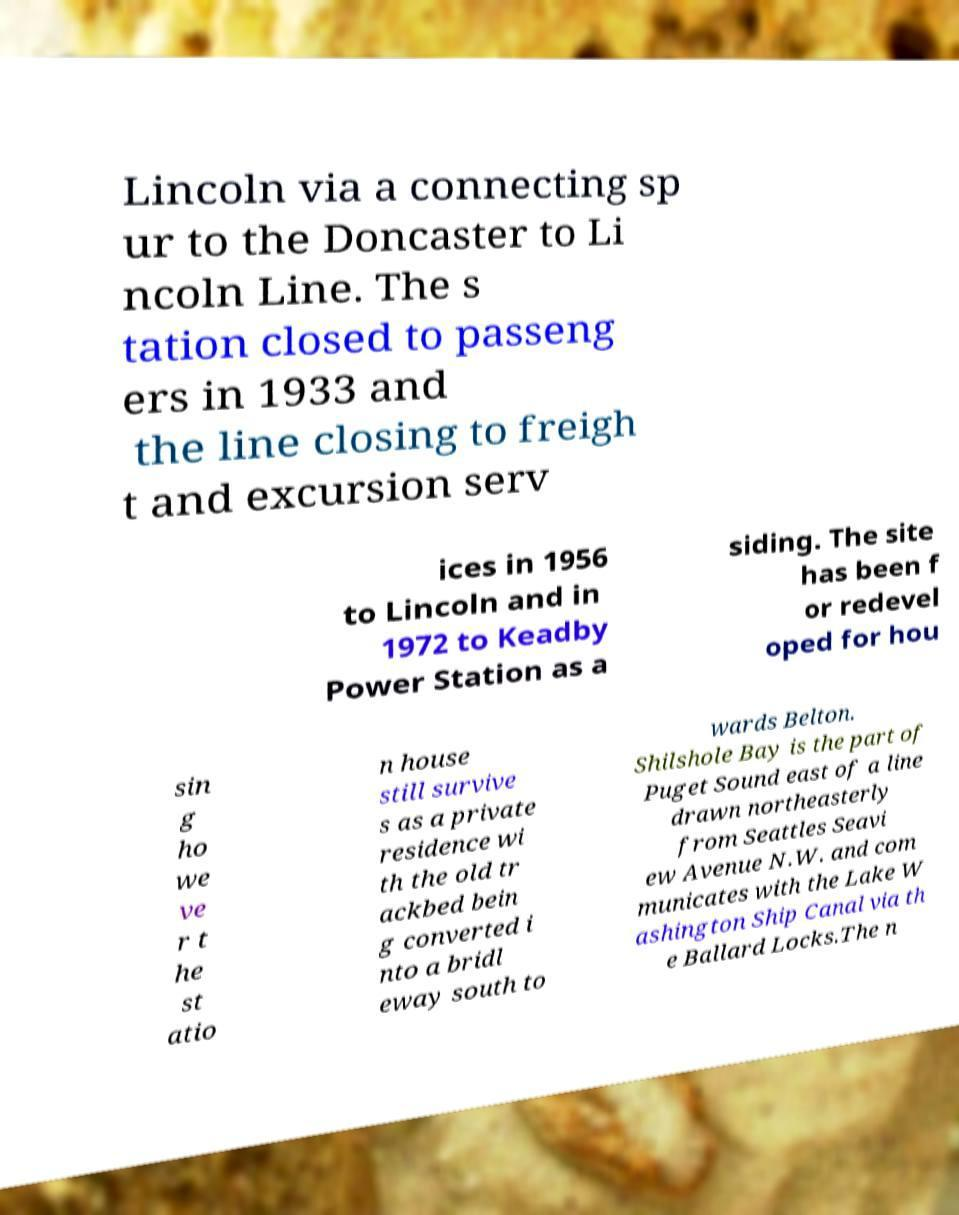Could you assist in decoding the text presented in this image and type it out clearly? Lincoln via a connecting sp ur to the Doncaster to Li ncoln Line. The s tation closed to passeng ers in 1933 and the line closing to freigh t and excursion serv ices in 1956 to Lincoln and in 1972 to Keadby Power Station as a siding. The site has been f or redevel oped for hou sin g ho we ve r t he st atio n house still survive s as a private residence wi th the old tr ackbed bein g converted i nto a bridl eway south to wards Belton. Shilshole Bay is the part of Puget Sound east of a line drawn northeasterly from Seattles Seavi ew Avenue N.W. and com municates with the Lake W ashington Ship Canal via th e Ballard Locks.The n 